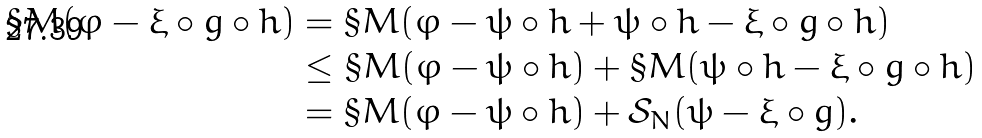<formula> <loc_0><loc_0><loc_500><loc_500>\S M ( \varphi - \xi \circ g \circ h ) & = \S M ( \varphi - \psi \circ h + \psi \circ h - \xi \circ g \circ h ) \\ & \leq \S M ( \varphi - \psi \circ h ) + \S M ( \psi \circ h - \xi \circ g \circ h ) \\ & = \S M ( \varphi - \psi \circ h ) + \mathcal { S } _ { N } ( \psi - \xi \circ g ) .</formula> 